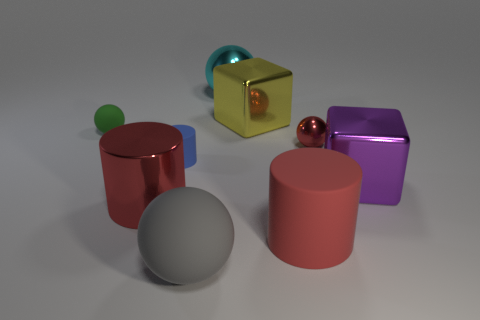What material is the green thing?
Keep it short and to the point. Rubber. There is a large cylinder to the right of the thing in front of the large rubber thing behind the big rubber sphere; what is its material?
Provide a succinct answer. Rubber. The red thing that is the same size as the green object is what shape?
Your answer should be very brief. Sphere. How many large shiny objects are in front of the green rubber sphere and right of the blue cylinder?
Provide a succinct answer. 1. Is the number of small red balls left of the gray rubber object less than the number of tiny green things?
Give a very brief answer. Yes. Is there a blue cylinder of the same size as the yellow thing?
Your answer should be very brief. No. There is another sphere that is the same material as the green sphere; what is its color?
Keep it short and to the point. Gray. What number of tiny objects are behind the tiny metallic object on the right side of the large cyan sphere?
Provide a succinct answer. 1. What is the big object that is both on the right side of the large gray sphere and in front of the large purple metal block made of?
Your response must be concise. Rubber. There is a large object that is to the right of the tiny red shiny ball; does it have the same shape as the large yellow thing?
Keep it short and to the point. Yes. 